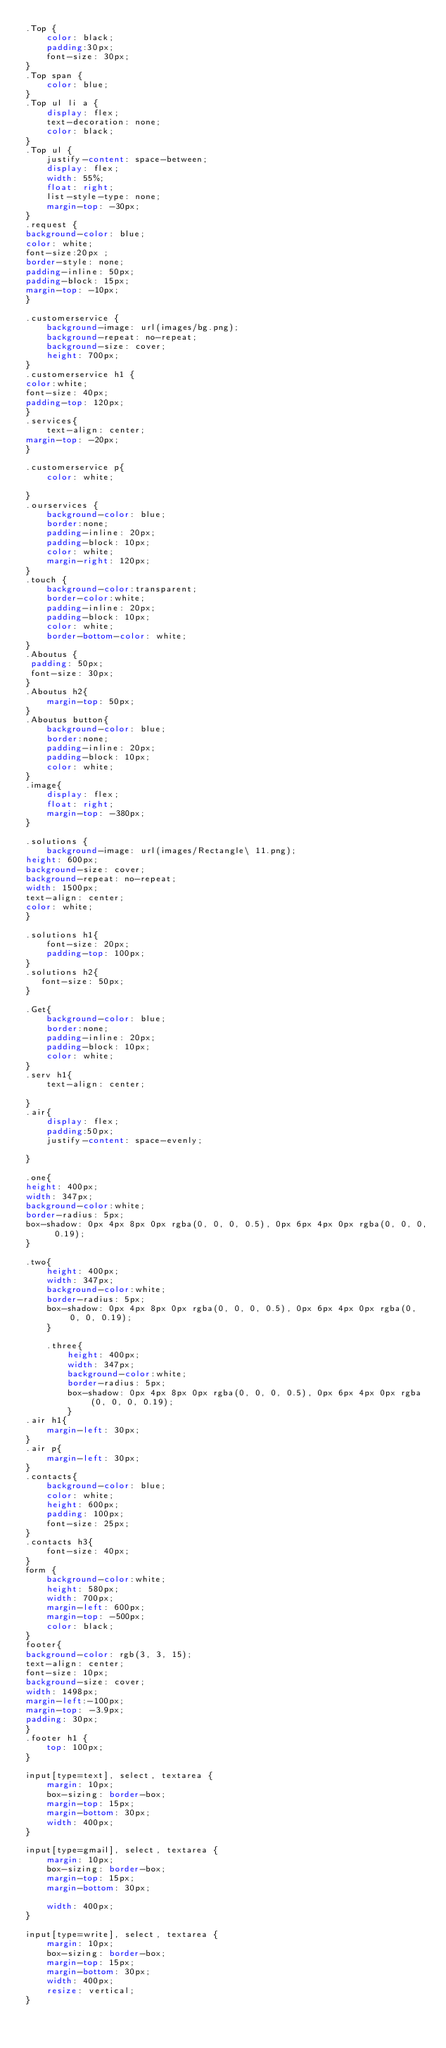Convert code to text. <code><loc_0><loc_0><loc_500><loc_500><_CSS_>.Top {
    color: black;
    padding:30px;
    font-size: 30px;
}
.Top span {
    color: blue;
}
.Top ul li a {
    display: flex;
    text-decoration: none;
    color: black;
}
.Top ul {
    justify-content: space-between;
    display: flex;
    width: 55%;
    float: right;
    list-style-type: none;
    margin-top: -30px;
}
.request {
background-color: blue;
color: white;
font-size:20px ;
border-style: none;
padding-inline: 50px;
padding-block: 15px;
margin-top: -10px;
}

.customerservice {
    background-image: url(images/bg.png);
    background-repeat: no-repeat;
    background-size: cover;
    height: 700px;
}
.customerservice h1 {
color:white;
font-size: 40px;
padding-top: 120px;
}
.services{
    text-align: center;
margin-top: -20px;
}

.customerservice p{
    color: white;

}
.ourservices {
    background-color: blue;
    border:none;
    padding-inline: 20px;
    padding-block: 10px;
    color: white;
    margin-right: 120px;
}
.touch { 
    background-color:transparent;
    border-color:white;
    padding-inline: 20px;
    padding-block: 10px;
    color: white;
    border-bottom-color: white;
}
.Aboutus {
 padding: 50px;
 font-size: 30px;
}
.Aboutus h2{
    margin-top: 50px;
}
.Aboutus button{
    background-color: blue;
    border:none;
    padding-inline: 20px;
    padding-block: 10px;
    color: white;
}
.image{
    display: flex;
    float: right;
    margin-top: -380px;
}

.solutions {
    background-image: url(images/Rectangle\ 11.png);
height: 600px;
background-size: cover;
background-repeat: no-repeat;
width: 1500px;
text-align: center;
color: white;
}

.solutions h1{
    font-size: 20px;
    padding-top: 100px;
}
.solutions h2{
   font-size: 50px;
}

.Get{
    background-color: blue;
    border:none;
    padding-inline: 20px;
    padding-block: 10px;
    color: white;
}
.serv h1{
    text-align: center;

}
.air{
    display: flex;
    padding:50px;
    justify-content: space-evenly;

}

.one{
height: 400px;
width: 347px;
background-color:white;
border-radius: 5px;
box-shadow: 0px 4px 8px 0px rgba(0, 0, 0, 0.5), 0px 6px 4px 0px rgba(0, 0, 0, 0.19);
}

.two{
    height: 400px;
    width: 347px;
    background-color:white;
    border-radius: 5px;
    box-shadow: 0px 4px 8px 0px rgba(0, 0, 0, 0.5), 0px 6px 4px 0px rgba(0, 0, 0, 0.19);
    }

    .three{
        height: 400px;
        width: 347px;
        background-color:white;
        border-radius: 5px;
        box-shadow: 0px 4px 8px 0px rgba(0, 0, 0, 0.5), 0px 6px 4px 0px rgba(0, 0, 0, 0.19);
        }
.air h1{
    margin-left: 30px;
}
.air p{
    margin-left: 30px;
}
.contacts{
    background-color: blue;
    color: white;
    height: 600px;
    padding: 100px;
    font-size: 25px;
}
.contacts h3{
    font-size: 40px;
}
form {
    background-color:white;
    height: 580px;
    width: 700px;
    margin-left: 600px;
    margin-top: -500px;
    color: black;
}
footer{
background-color: rgb(3, 3, 15);
text-align: center;
font-size: 10px;
background-size: cover;
width: 1498px;
margin-left:-100px;
margin-top: -3.9px;
padding: 30px;
}
.footer h1 {
    top: 100px;
}

input[type=text], select, textarea {
    margin: 10px;
    box-sizing: border-box;
    margin-top: 15px;
    margin-bottom: 30px;
    width: 400px;
}

input[type=gmail], select, textarea {
    margin: 10px;
    box-sizing: border-box;
    margin-top: 15px;
    margin-bottom: 30px;

    width: 400px;
}

input[type=write], select, textarea {
    margin: 10px;
    box-sizing: border-box;
    margin-top: 15px;
    margin-bottom: 30px;
    width: 400px;
    resize: vertical;
}

</code> 